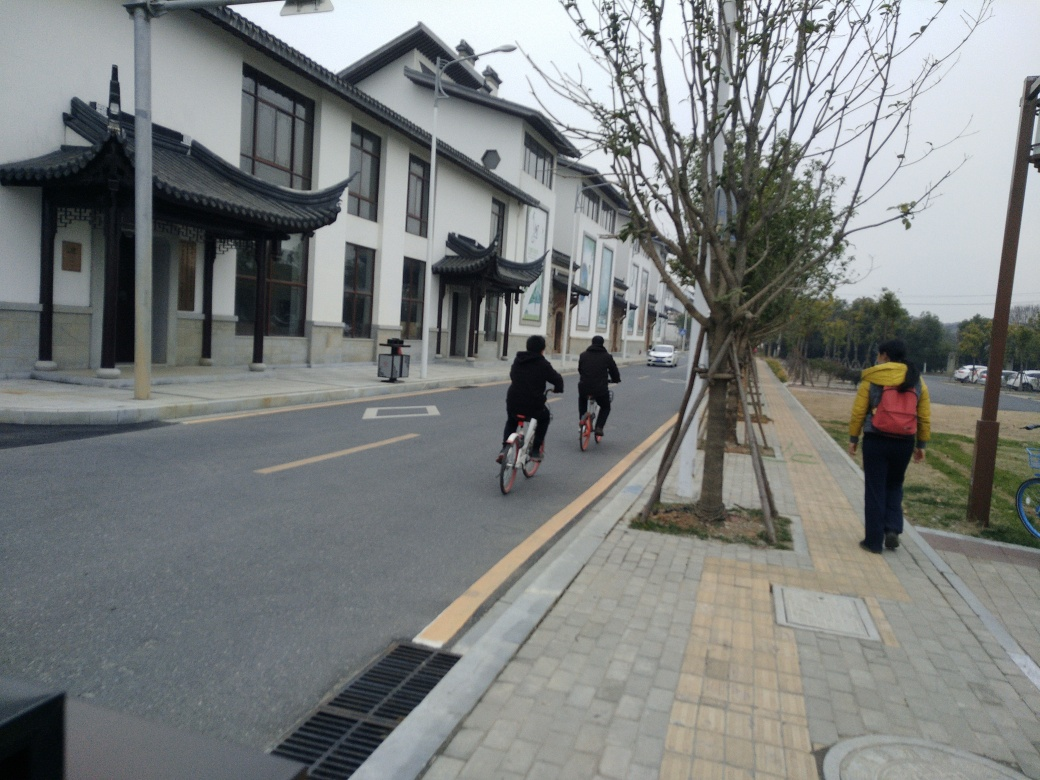Can you tell me about the activities people are engaging in within this photo? In the image, there are two individuals riding bicycles, likely for transportation or leisure. Additionally, there's a pedestrian on the sidewalk who appears to be walking, potentially observing the surroundings or enjoying a leisurely stroll. What does the presence of the bicycles suggest about the location? The presence of bicycles, along with the dedicated bike lane, suggests that this location is bike-friendly and possibly encourages eco-friendly modes of transportation. It may be an area where commuting by bike is common or encouraged. 